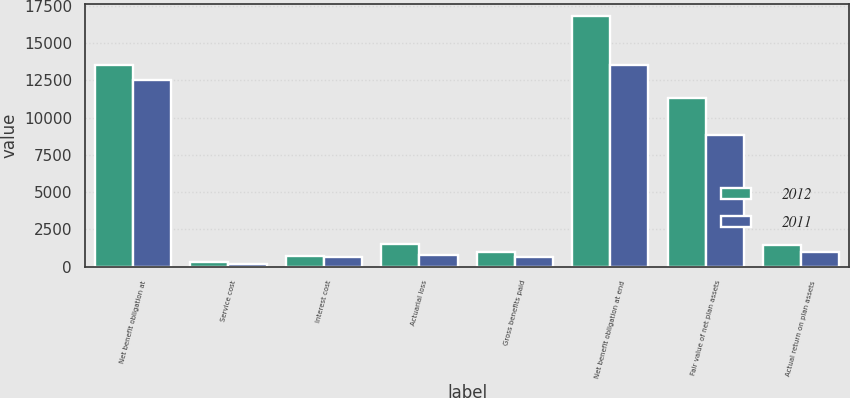Convert chart. <chart><loc_0><loc_0><loc_500><loc_500><stacked_bar_chart><ecel><fcel>Net benefit obligation at<fcel>Service cost<fcel>Interest cost<fcel>Actuarial loss<fcel>Gross benefits paid<fcel>Net benefit obligation at end<fcel>Fair value of net plan assets<fcel>Actual return on plan assets<nl><fcel>2012<fcel>13538<fcel>280<fcel>698<fcel>1520<fcel>952<fcel>16800<fcel>11302<fcel>1484<nl><fcel>2011<fcel>12524<fcel>212<fcel>649<fcel>807<fcel>654<fcel>13538<fcel>8859<fcel>1003<nl></chart> 